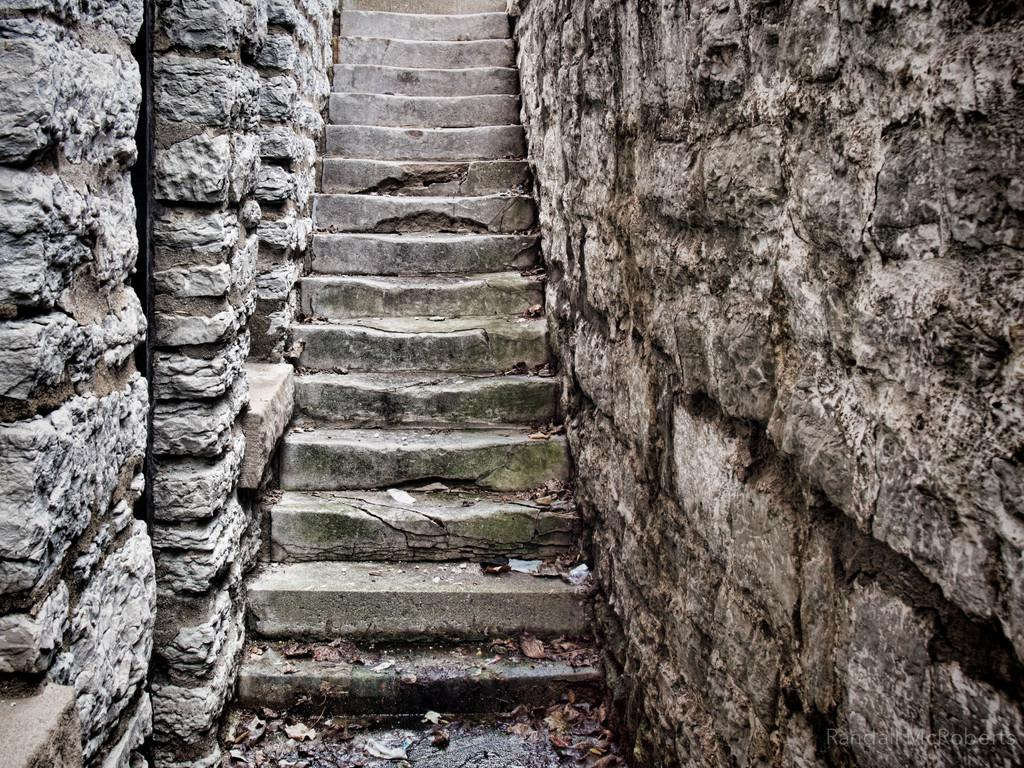What type of material is used to construct the walls in the image? The walls in the image are made up of rocks. What feature connects the two walls in the image? There are stairs between the walls in the image. What type of yarn is used to cover the walls in the image? There is no yarn present in the image, and the walls are made up of rocks, not covered by any material. 